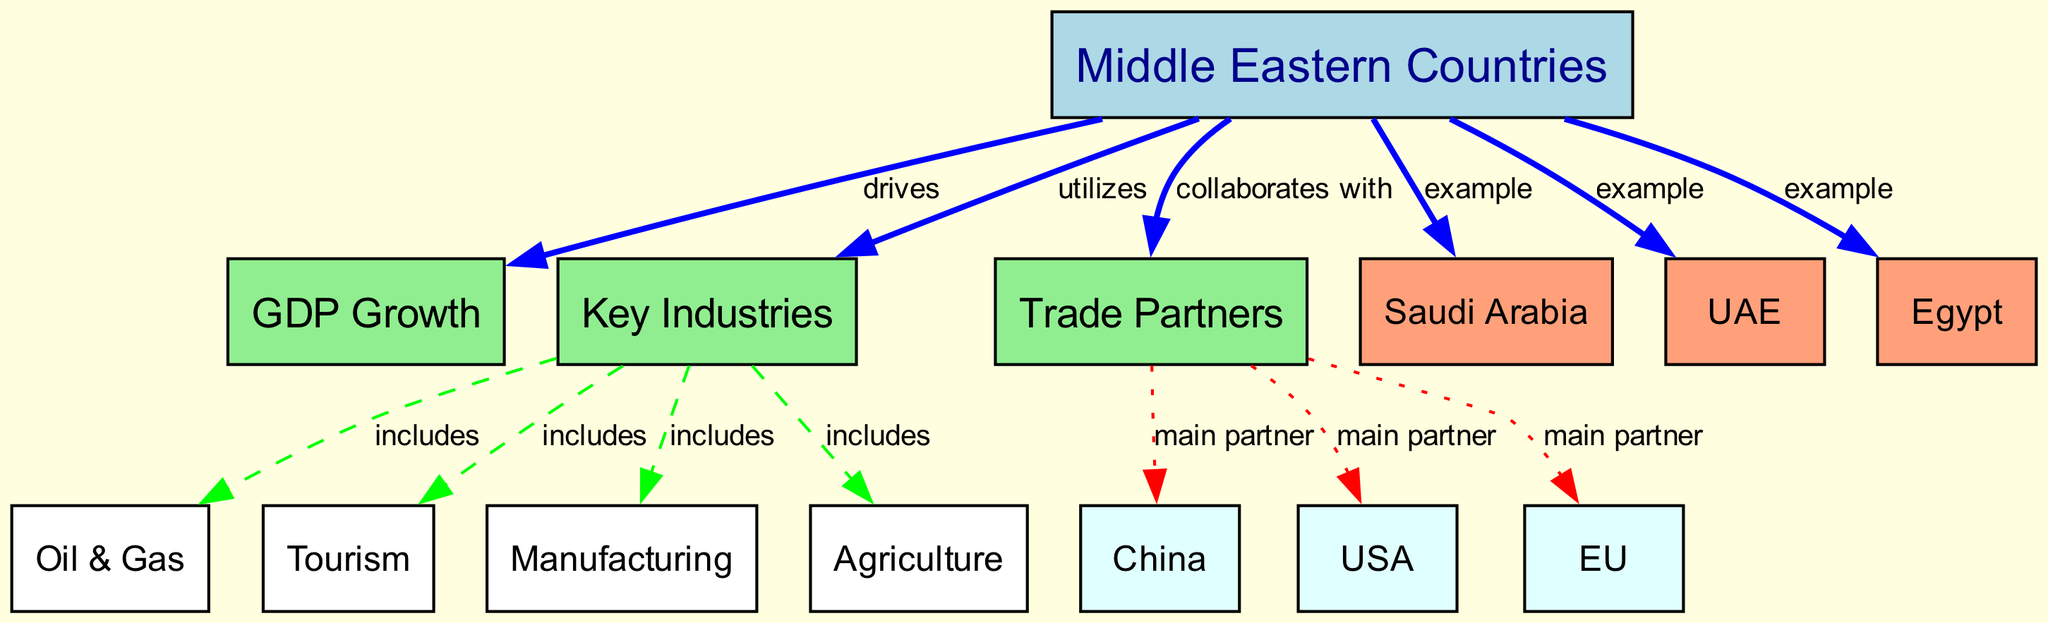What nodes are included in the diagram? The diagram contains nodes representing GDP Growth, Key Industries, Trade Partners, and several Middle Eastern countries including Saudi Arabia, UAE, and Egypt.
Answer: GDP Growth, Key Industries, Trade Partners, Saudi Arabia, UAE, Egypt Which country is an example in the Middle East? The diagram includes Saudi Arabia, UAE, and Egypt as examples of Middle Eastern countries.
Answer: Saudi Arabia, UAE, Egypt How many key industries are included in the diagram? By analyzing the connections, we see that there are four key industries listed: Oil & Gas, Tourism, Manufacturing, and Agriculture.
Answer: Four What is the main trade partner of Middle Eastern countries? The diagram indicates China, USA, and EU as the main trade partners of Middle Eastern countries.
Answer: China, USA, EU What drives GDP growth in Middle Eastern countries? The flow in the diagram illustrates that GDP Growth is driven by the characteristics and exchanges of Middle Eastern countries.
Answer: Middle Eastern countries Which industry is included in both the key industries and drives GDP growth? The industry of Oil & Gas is included in the key industries and contributes to GDP growth as shown in the diagram.
Answer: Oil & Gas What relationship exists between key industries and trade partners? The diagram does not explicitly illustrate a direct relationship between key industries and trade partners; rather, it connects independently to their respective traits. However, both contribute to economic factors of the Middle East.
Answer: None directly shown Which industry includes Tourism? The Tourism node is included under the Key Industries category in the diagram.
Answer: Key Industries 